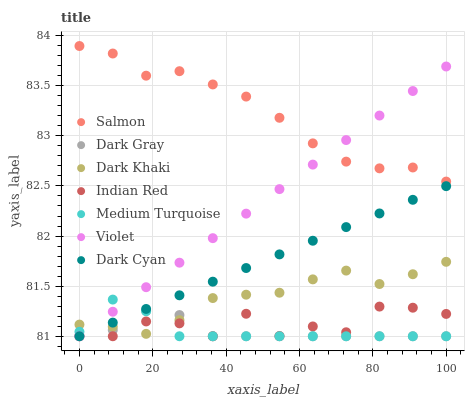Does Dark Gray have the minimum area under the curve?
Answer yes or no. Yes. Does Salmon have the maximum area under the curve?
Answer yes or no. Yes. Does Indian Red have the minimum area under the curve?
Answer yes or no. No. Does Indian Red have the maximum area under the curve?
Answer yes or no. No. Is Dark Cyan the smoothest?
Answer yes or no. Yes. Is Indian Red the roughest?
Answer yes or no. Yes. Is Salmon the smoothest?
Answer yes or no. No. Is Salmon the roughest?
Answer yes or no. No. Does Indian Red have the lowest value?
Answer yes or no. Yes. Does Salmon have the lowest value?
Answer yes or no. No. Does Salmon have the highest value?
Answer yes or no. Yes. Does Indian Red have the highest value?
Answer yes or no. No. Is Medium Turquoise less than Salmon?
Answer yes or no. Yes. Is Salmon greater than Medium Turquoise?
Answer yes or no. Yes. Does Medium Turquoise intersect Dark Cyan?
Answer yes or no. Yes. Is Medium Turquoise less than Dark Cyan?
Answer yes or no. No. Is Medium Turquoise greater than Dark Cyan?
Answer yes or no. No. Does Medium Turquoise intersect Salmon?
Answer yes or no. No. 